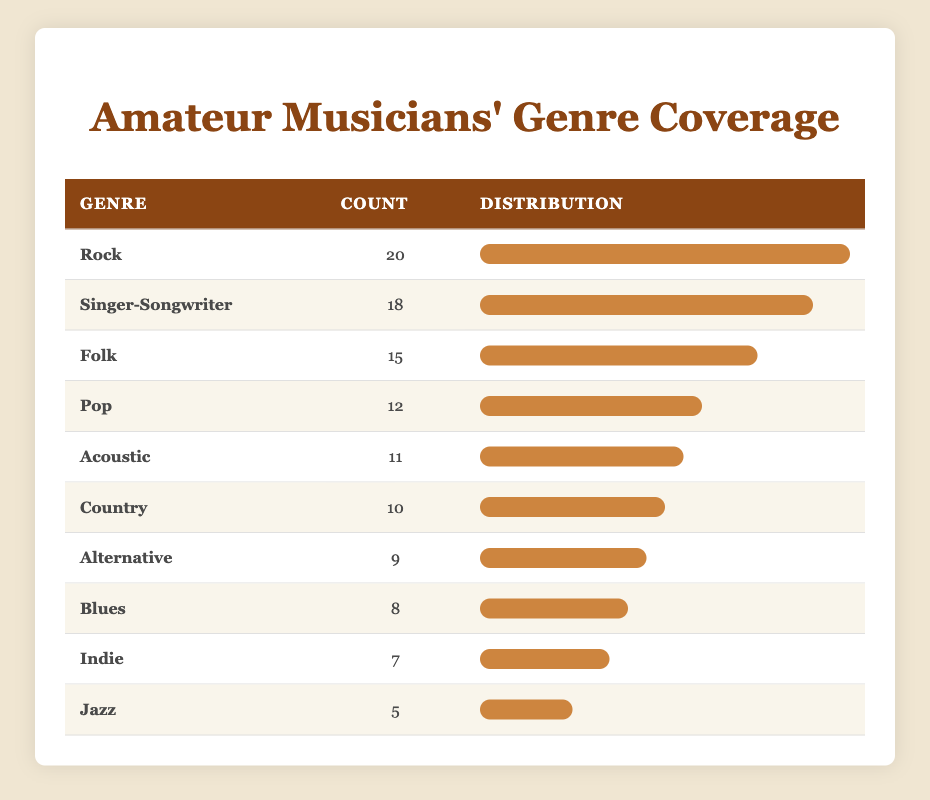What is the most covered genre by amateur musicians? The table lists different genres along with their counts. By checking the counts, Rock has the highest count of 20, making it the most covered genre.
Answer: Rock How many genres have a coverage count of 10 or more? The genres with 10 or more counts are: Folk (15), Rock (20), Singer-Songwriter (18), Pop (12), Acoustic (11), and Country (10). This makes a total of 6 genres.
Answer: 6 What is the total coverage count of all genres combined? To find the total coverage count, add all the individual counts: 15 + 20 + 10 + 8 + 12 + 5 + 7 + 18 + 9 + 11 =  115.
Answer: 115 Is Jazz one of the top three most covered genres? The counts for the top three genres are: Rock (20), Singer-Songwriter (18), and Folk (15). Jazz, with a count of 5, does not make the top three.
Answer: No What is the difference between the counts of Rock and Jazz? The count for Rock is 20 and for Jazz it is 5. The difference is 20 - 5 = 15.
Answer: 15 What percentage of the total coverage does the Singer-Songwriter genre represent? The count for Singer-Songwriter is 18. The total coverage is 115. To find the percentage, calculate (18 / 115) * 100 = 15.65%.
Answer: 15.65% Which genres have a coverage count less than 10? Reviewing the counts, the genres with a count less than 10 are Blues (8), Indie (7), and Jazz (5). This totals to 3 genres.
Answer: 3 What is the average coverage count for genres listed in this table? To find the average, sum the counts (115) and divide by the number of genres (10). Hence, 115/10 = 11.5.
Answer: 11.5 Which genre has the smallest count and what is it? The genres are listed with their respective counts. Jazz has the smallest count of 5.
Answer: Jazz 